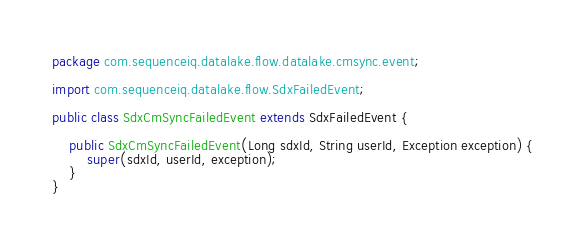<code> <loc_0><loc_0><loc_500><loc_500><_Java_>package com.sequenceiq.datalake.flow.datalake.cmsync.event;

import com.sequenceiq.datalake.flow.SdxFailedEvent;

public class SdxCmSyncFailedEvent extends SdxFailedEvent {

    public SdxCmSyncFailedEvent(Long sdxId, String userId, Exception exception) {
        super(sdxId, userId, exception);
    }
}
</code> 